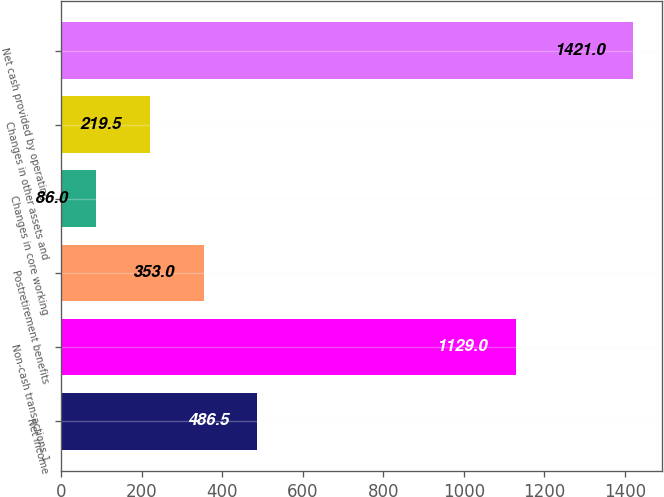Convert chart. <chart><loc_0><loc_0><loc_500><loc_500><bar_chart><fcel>Net income<fcel>Non-cash transactions 1<fcel>Postretirement benefits<fcel>Changes in core working<fcel>Changes in other assets and<fcel>Net cash provided by operating<nl><fcel>486.5<fcel>1129<fcel>353<fcel>86<fcel>219.5<fcel>1421<nl></chart> 